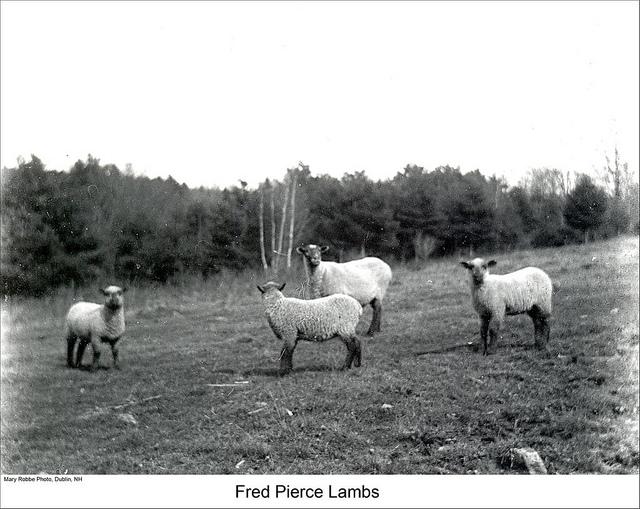Is this an old image?
Concise answer only. Yes. How many sheep are there?
Give a very brief answer. 4. Are the sheep in the woods?
Concise answer only. No. 